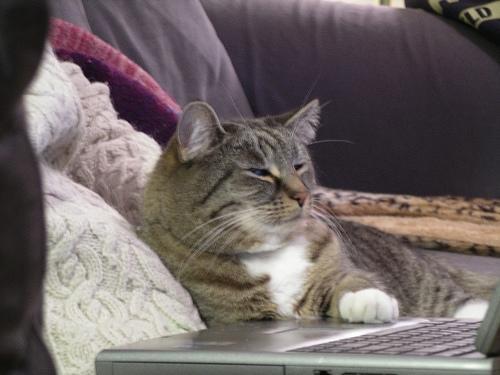What is similar to the long things on the animal's face?
Select the accurate response from the four choices given to answer the question.
Options: Antenna, gills, unicorn horn, fins. Antenna. 